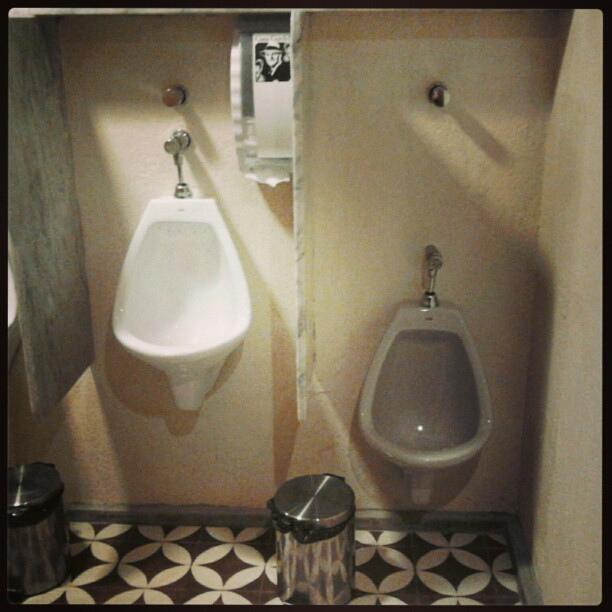How many urinals are there?
Give a very brief answer. 2. How many toilets can you see?
Give a very brief answer. 2. How many people in the picture are wearing the same yellow t-shirt?
Give a very brief answer. 0. 